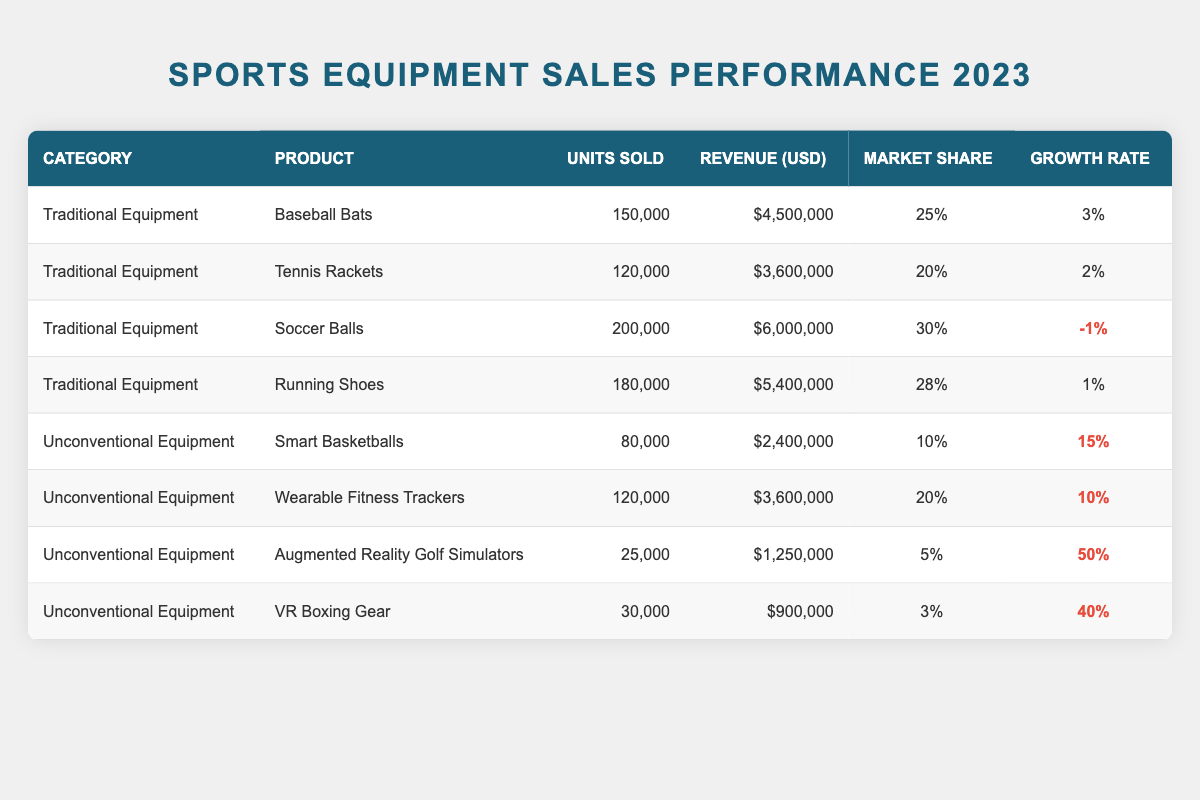What is the total revenue of Traditional Equipment sales in 2023? The revenue from each Traditional Equipment product is as follows: Baseball Bats ($4,500,000), Tennis Rackets ($3,600,000), Soccer Balls ($6,000,000), and Running Shoes ($5,400,000). Summing these amounts gives $4,500,000 + $3,600,000 + $6,000,000 + $5,400,000 = $19,500,000.
Answer: $19,500,000 Which product had the highest market share in Traditional Equipment? The market shares for Traditional Equipment are: Baseball Bats (25%), Tennis Rackets (20%), Soccer Balls (30%), and Running Shoes (28%). Soccer Balls has the highest market share at 30%.
Answer: Soccer Balls What is the growth rate of Wearable Fitness Trackers? The growth rate of Wearable Fitness Trackers is provided directly in the table as 10%.
Answer: 10% How many more units were sold for Soccer Balls than VR Boxing Gear? Units sold for Soccer Balls is 200,000 and for VR Boxing Gear is 30,000. The difference is 200,000 - 30,000 = 170,000.
Answer: 170,000 Is the growth rate of Smart Basketballs greater than that of Traditional Equipment on average? The growth rates for Traditional Equipment are: 3%, 2%, -1%, and 1%, averaging to (3 + 2 - 1 + 1) / 4 = 1.25%. The growth rate for Smart Basketballs is 15%. Since 15% > 1.25%, the statement is true.
Answer: Yes What percentage of units sold do Augmented Reality Golf Simulators represent compared to the total units sold across all products? Augmented Reality Golf Simulators sold 25,000 units. The total units sold are 150,000 + 120,000 + 200,000 + 180,000 + 80,000 + 120,000 + 25,000 + 30,000 = 905,000. The percentage is (25,000 / 905,000) * 100 ≈ 2.76%.
Answer: Approximately 2.76% Which category had a product with a growth rate above 40%? In the Unconventional Equipment category, both Augmented Reality Golf Simulators (50%) and VR Boxing Gear (40%) have growth rates above 40%. The presence of a product with this growth rate confirms the finding.
Answer: Yes What is the average growth rate for all Unconventional Equipment? The growth rates for Unconventional Equipment are 15%, 10%, 50%, and 40%. Summing these gives 15 + 10 + 50 + 40 = 115. The average is 115 / 4 = 28.75%.
Answer: 28.75% What is the total market share percentage for all Conventional Equipment combined? The market shares for Traditional Equipment are: 25%, 20%, 30%, and 28%. Hence, the total market share is 25 + 20 + 30 + 28 = 103%.
Answer: 103% Did any traditional equipment experience a negative growth rate in 2023? The growth rate for Soccer Balls is -1%, indicating a decrease. Therefore, yes, at least one traditional equipment shows negative growth.
Answer: Yes 